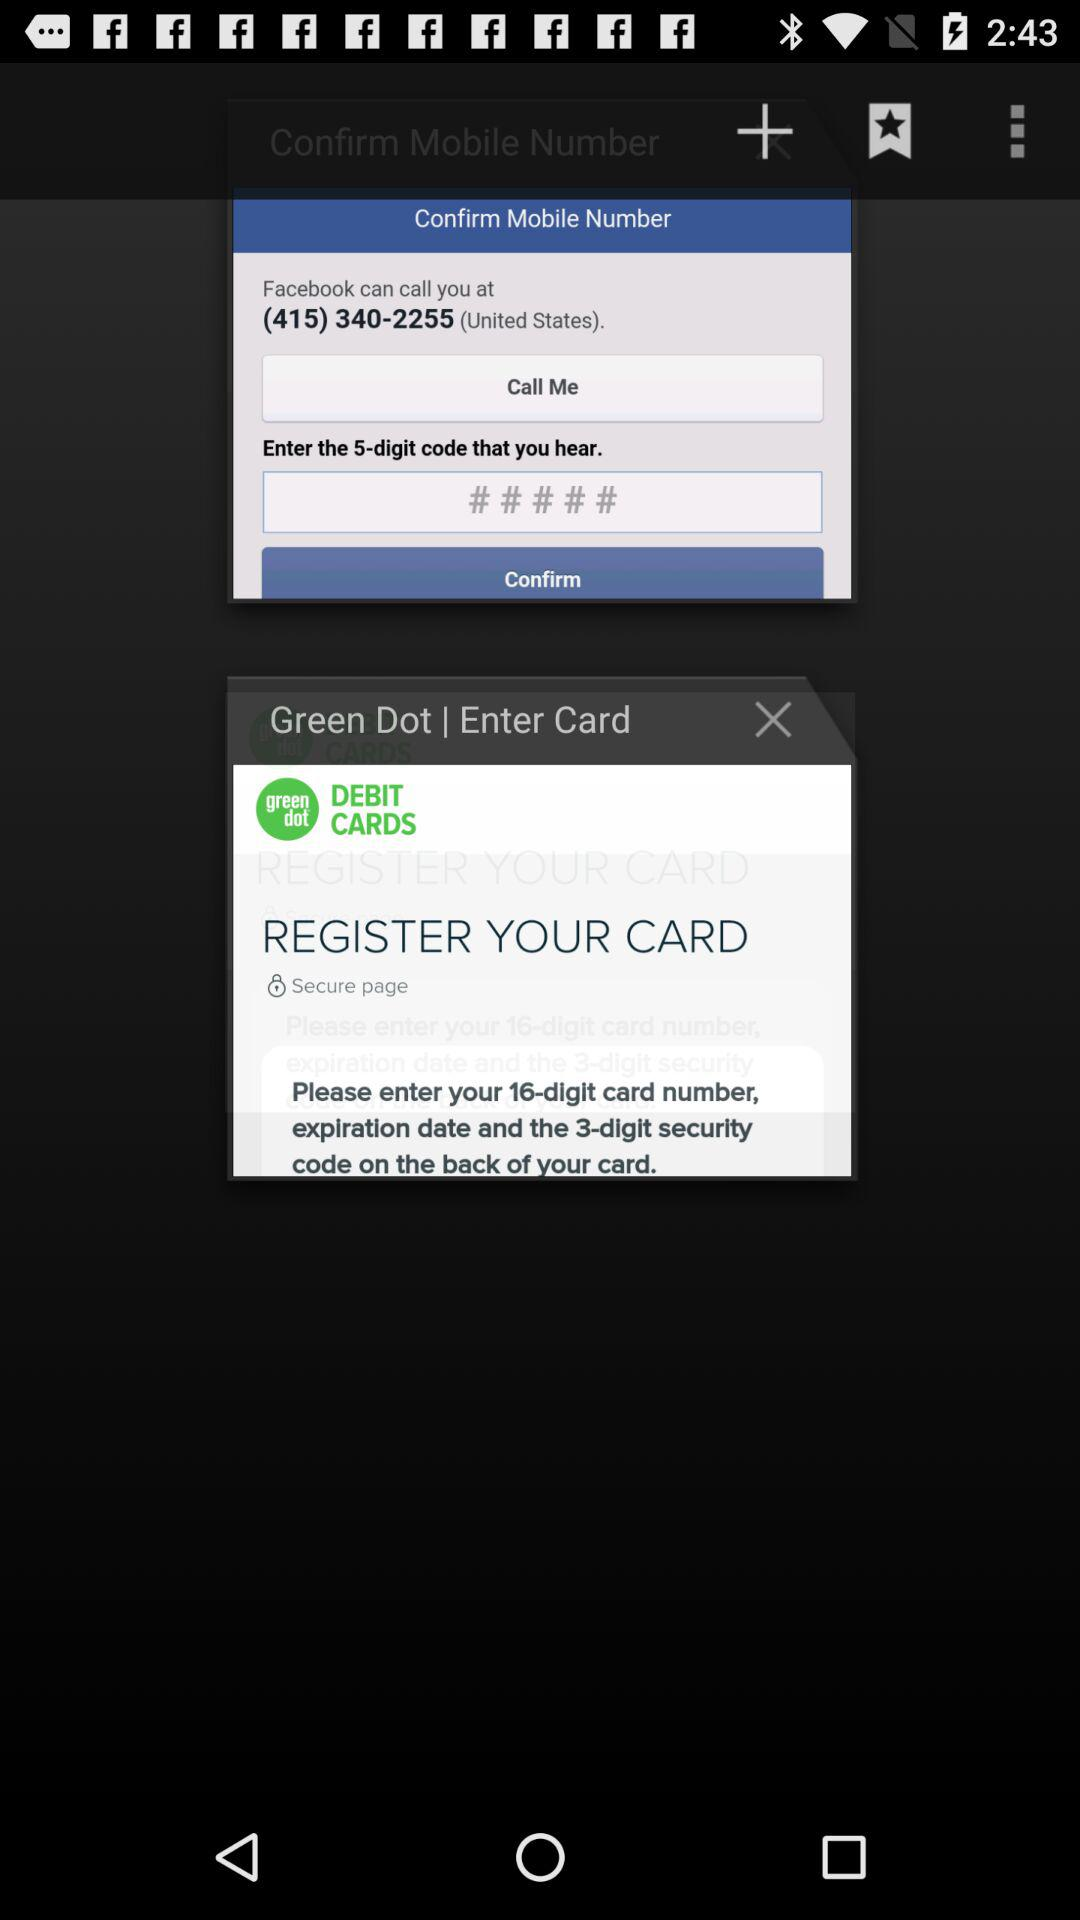What is the contact number? The contact number is (415) 340-2255. 